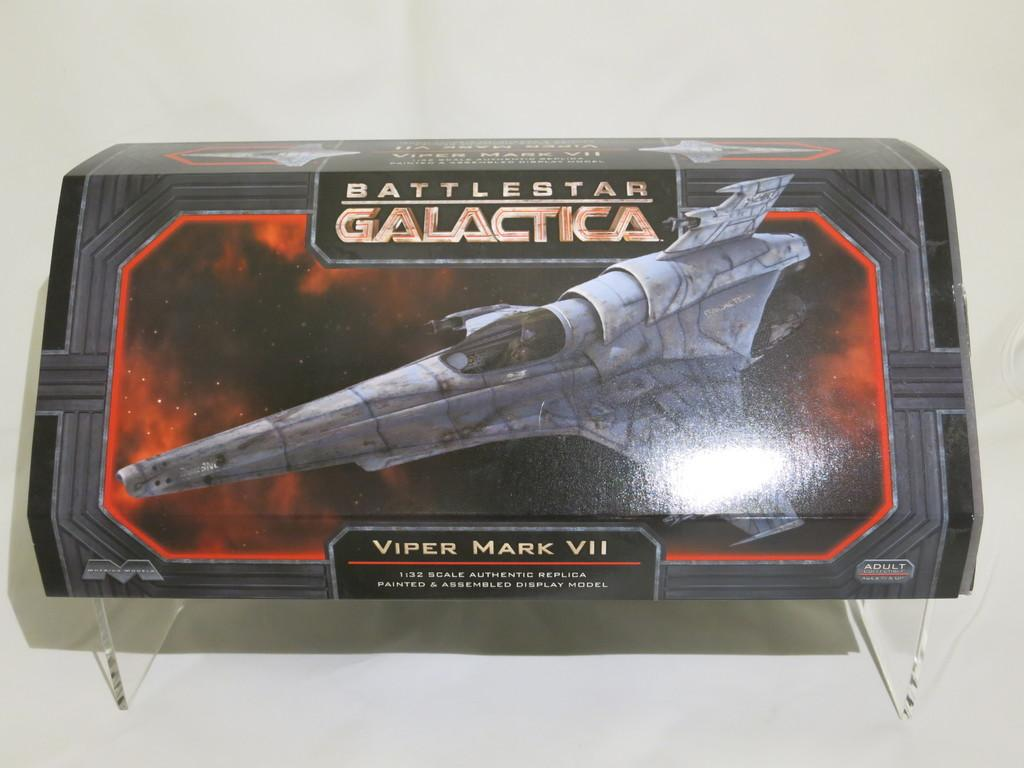<image>
Give a short and clear explanation of the subsequent image. A Viper Mark VII model is part of the Battlestar Galactica series. 